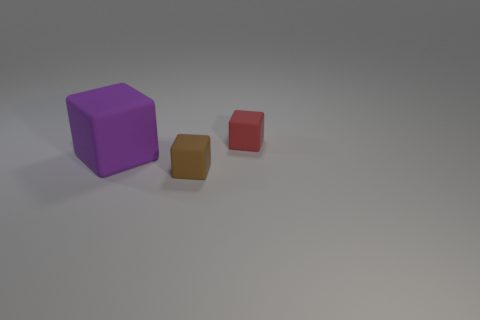Add 2 big purple matte cubes. How many objects exist? 5 Subtract all purple blocks. How many blocks are left? 2 Subtract all brown blocks. How many blocks are left? 2 Subtract 1 blocks. How many blocks are left? 2 Subtract all green cylinders. How many brown blocks are left? 1 Subtract all red cubes. Subtract all yellow balls. How many cubes are left? 2 Subtract all red objects. Subtract all small red blocks. How many objects are left? 1 Add 3 red things. How many red things are left? 4 Add 1 big rubber cubes. How many big rubber cubes exist? 2 Subtract 0 green cylinders. How many objects are left? 3 